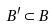<formula> <loc_0><loc_0><loc_500><loc_500>B ^ { \prime } \subset B</formula> 